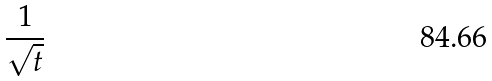Convert formula to latex. <formula><loc_0><loc_0><loc_500><loc_500>\frac { 1 } { \sqrt { t } }</formula> 